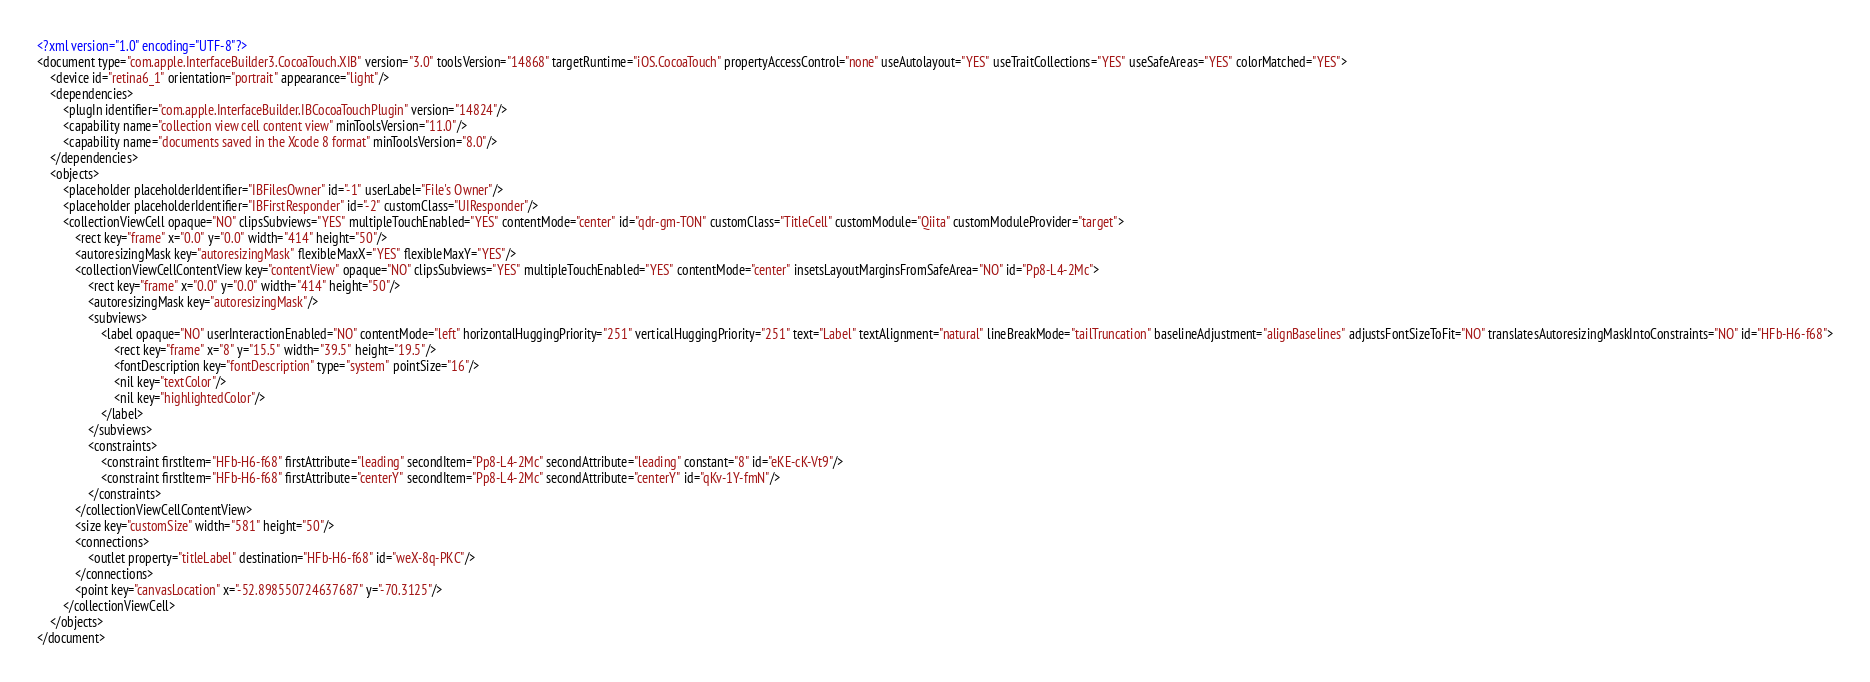<code> <loc_0><loc_0><loc_500><loc_500><_XML_><?xml version="1.0" encoding="UTF-8"?>
<document type="com.apple.InterfaceBuilder3.CocoaTouch.XIB" version="3.0" toolsVersion="14868" targetRuntime="iOS.CocoaTouch" propertyAccessControl="none" useAutolayout="YES" useTraitCollections="YES" useSafeAreas="YES" colorMatched="YES">
    <device id="retina6_1" orientation="portrait" appearance="light"/>
    <dependencies>
        <plugIn identifier="com.apple.InterfaceBuilder.IBCocoaTouchPlugin" version="14824"/>
        <capability name="collection view cell content view" minToolsVersion="11.0"/>
        <capability name="documents saved in the Xcode 8 format" minToolsVersion="8.0"/>
    </dependencies>
    <objects>
        <placeholder placeholderIdentifier="IBFilesOwner" id="-1" userLabel="File's Owner"/>
        <placeholder placeholderIdentifier="IBFirstResponder" id="-2" customClass="UIResponder"/>
        <collectionViewCell opaque="NO" clipsSubviews="YES" multipleTouchEnabled="YES" contentMode="center" id="qdr-gm-TON" customClass="TitleCell" customModule="Qiita" customModuleProvider="target">
            <rect key="frame" x="0.0" y="0.0" width="414" height="50"/>
            <autoresizingMask key="autoresizingMask" flexibleMaxX="YES" flexibleMaxY="YES"/>
            <collectionViewCellContentView key="contentView" opaque="NO" clipsSubviews="YES" multipleTouchEnabled="YES" contentMode="center" insetsLayoutMarginsFromSafeArea="NO" id="Pp8-L4-2Mc">
                <rect key="frame" x="0.0" y="0.0" width="414" height="50"/>
                <autoresizingMask key="autoresizingMask"/>
                <subviews>
                    <label opaque="NO" userInteractionEnabled="NO" contentMode="left" horizontalHuggingPriority="251" verticalHuggingPriority="251" text="Label" textAlignment="natural" lineBreakMode="tailTruncation" baselineAdjustment="alignBaselines" adjustsFontSizeToFit="NO" translatesAutoresizingMaskIntoConstraints="NO" id="HFb-H6-f68">
                        <rect key="frame" x="8" y="15.5" width="39.5" height="19.5"/>
                        <fontDescription key="fontDescription" type="system" pointSize="16"/>
                        <nil key="textColor"/>
                        <nil key="highlightedColor"/>
                    </label>
                </subviews>
                <constraints>
                    <constraint firstItem="HFb-H6-f68" firstAttribute="leading" secondItem="Pp8-L4-2Mc" secondAttribute="leading" constant="8" id="eKE-cK-Vt9"/>
                    <constraint firstItem="HFb-H6-f68" firstAttribute="centerY" secondItem="Pp8-L4-2Mc" secondAttribute="centerY" id="qKv-1Y-fmN"/>
                </constraints>
            </collectionViewCellContentView>
            <size key="customSize" width="581" height="50"/>
            <connections>
                <outlet property="titleLabel" destination="HFb-H6-f68" id="weX-8q-PKC"/>
            </connections>
            <point key="canvasLocation" x="-52.898550724637687" y="-70.3125"/>
        </collectionViewCell>
    </objects>
</document>
</code> 